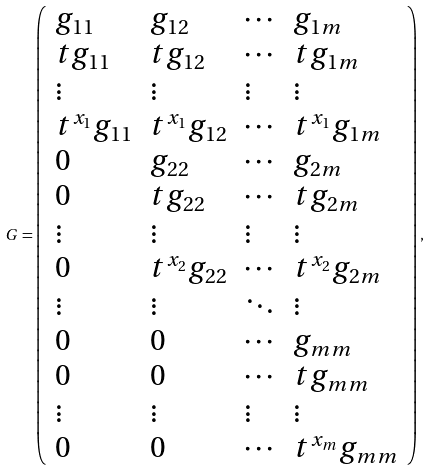<formula> <loc_0><loc_0><loc_500><loc_500>G = \left ( \begin{array} { l l l l } g _ { 1 1 } & g _ { 1 2 } & \cdots & g _ { 1 m } \\ t g _ { 1 1 } & t g _ { 1 2 } & \cdots & t g _ { 1 m } \\ \vdots & \vdots & \vdots & \vdots \\ t ^ { x _ { 1 } } g _ { 1 1 } & t ^ { x _ { 1 } } g _ { 1 2 } & \cdots & t ^ { x _ { 1 } } g _ { 1 m } \\ 0 & g _ { 2 2 } & \cdots & g _ { 2 m } \\ 0 & t g _ { 2 2 } & \cdots & t g _ { 2 m } \\ \vdots & \vdots & \vdots & \vdots \\ 0 & t ^ { x _ { 2 } } g _ { 2 2 } & \cdots & t ^ { x _ { 2 } } g _ { 2 m } \\ \vdots & \vdots & \ddots & \vdots \\ 0 & 0 & \cdots & g _ { m m } \\ 0 & 0 & \cdots & t g _ { m m } \\ \vdots & \vdots & \vdots & \vdots \\ 0 & 0 & \cdots & t ^ { x _ { m } } g _ { m m } \end{array} \right ) ,</formula> 